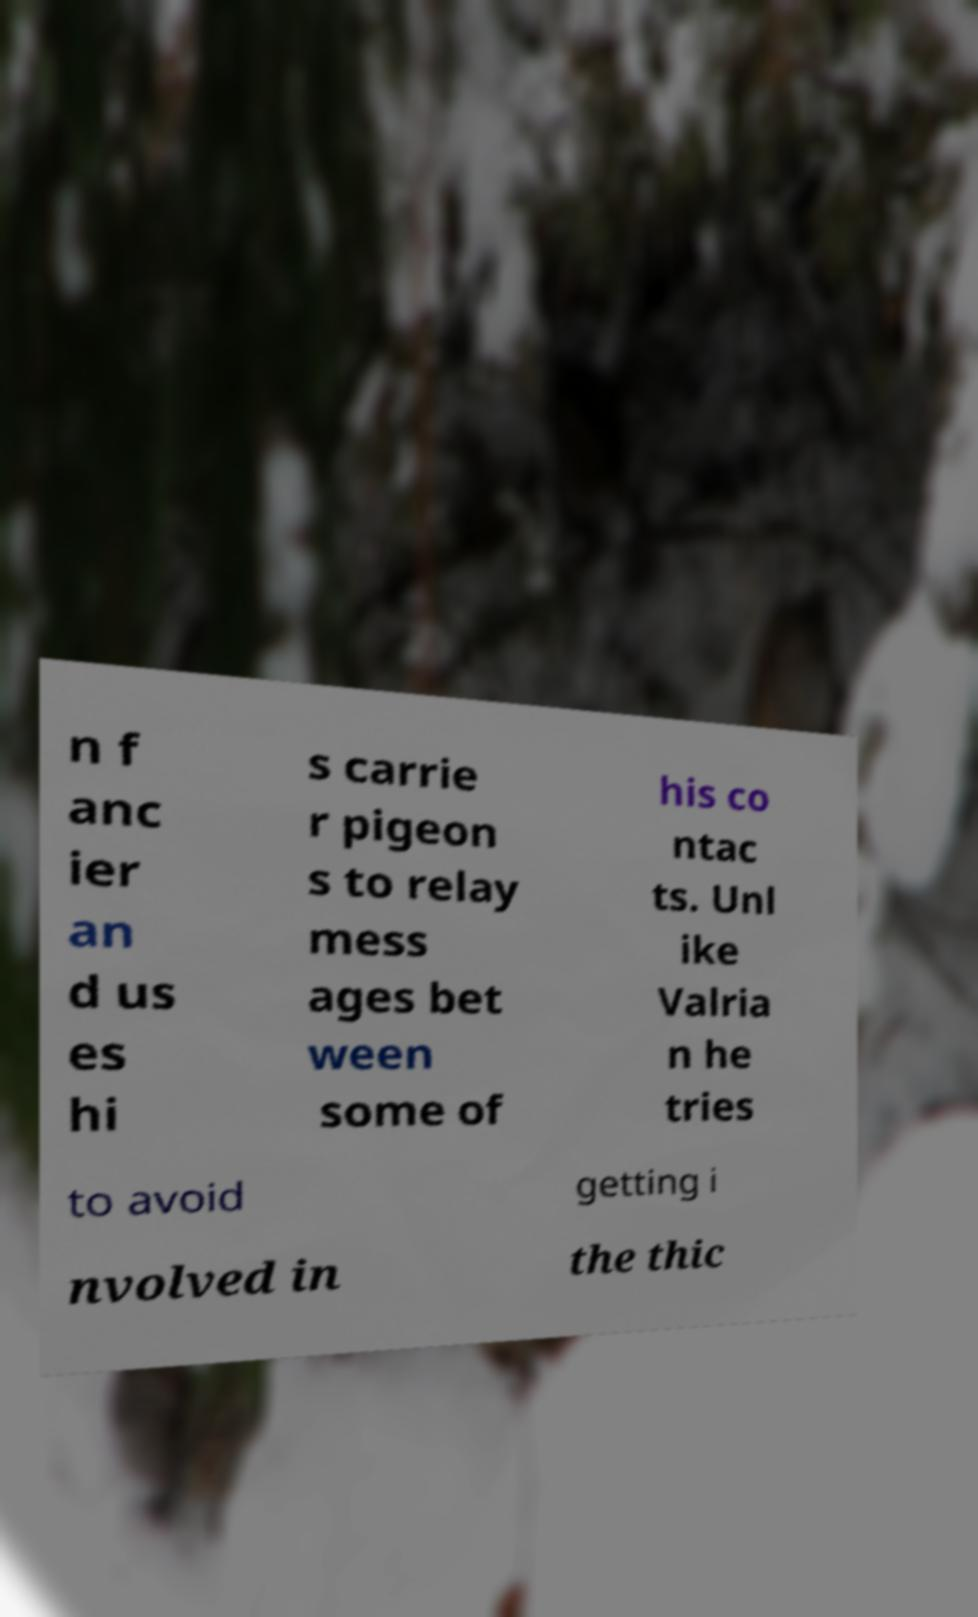I need the written content from this picture converted into text. Can you do that? n f anc ier an d us es hi s carrie r pigeon s to relay mess ages bet ween some of his co ntac ts. Unl ike Valria n he tries to avoid getting i nvolved in the thic 